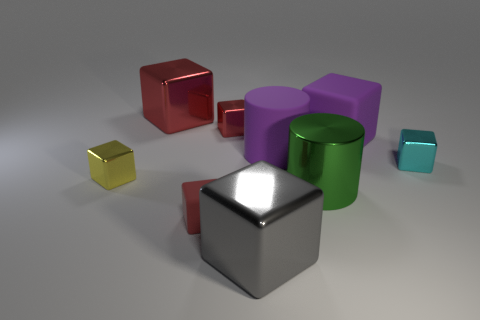Subtract all red cylinders. How many red cubes are left? 3 Subtract 3 blocks. How many blocks are left? 4 Subtract all cyan metallic cubes. How many cubes are left? 6 Subtract all gray cubes. How many cubes are left? 6 Subtract all red cubes. Subtract all blue cylinders. How many cubes are left? 4 Add 1 gray things. How many objects exist? 10 Subtract all cylinders. How many objects are left? 7 Subtract 0 yellow cylinders. How many objects are left? 9 Subtract all small cubes. Subtract all cyan objects. How many objects are left? 4 Add 2 big gray metal things. How many big gray metal things are left? 3 